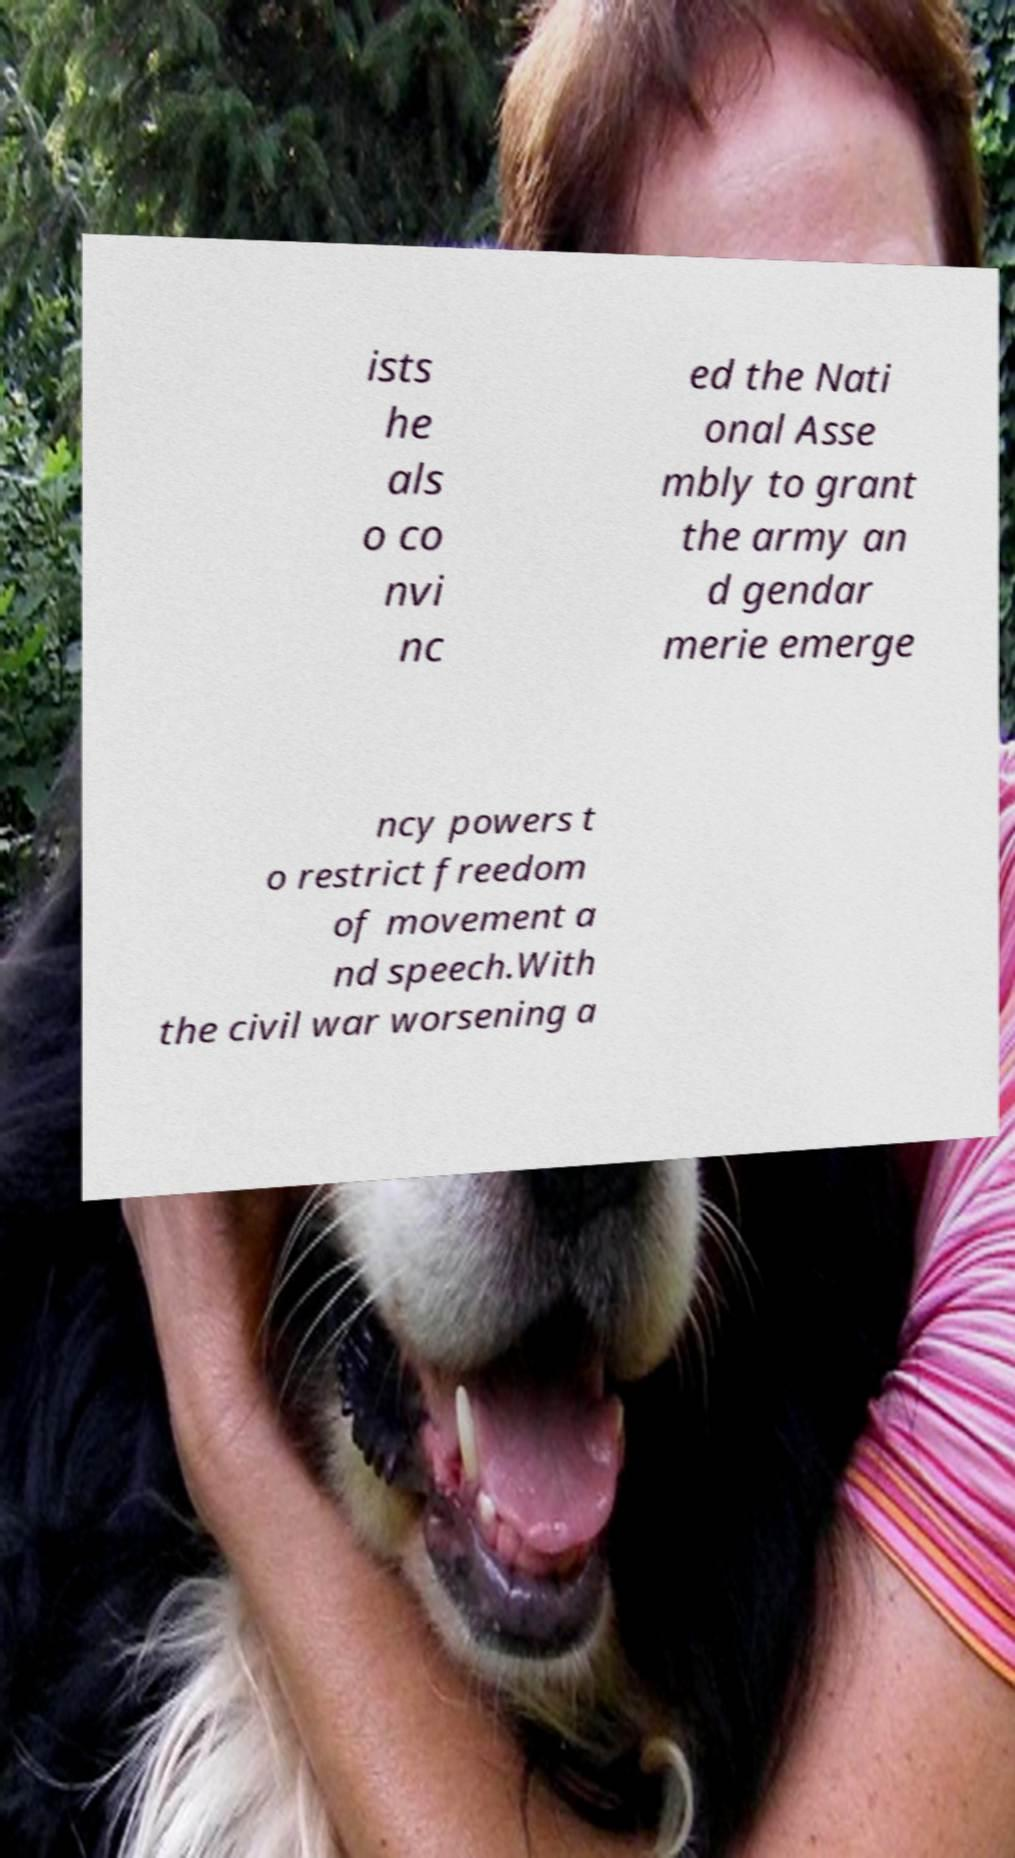I need the written content from this picture converted into text. Can you do that? ists he als o co nvi nc ed the Nati onal Asse mbly to grant the army an d gendar merie emerge ncy powers t o restrict freedom of movement a nd speech.With the civil war worsening a 